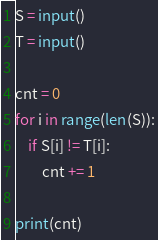Convert code to text. <code><loc_0><loc_0><loc_500><loc_500><_Python_>S = input()
T = input()

cnt = 0
for i in range(len(S)):
	if S[i] != T[i]:
		cnt += 1

print(cnt) 
</code> 